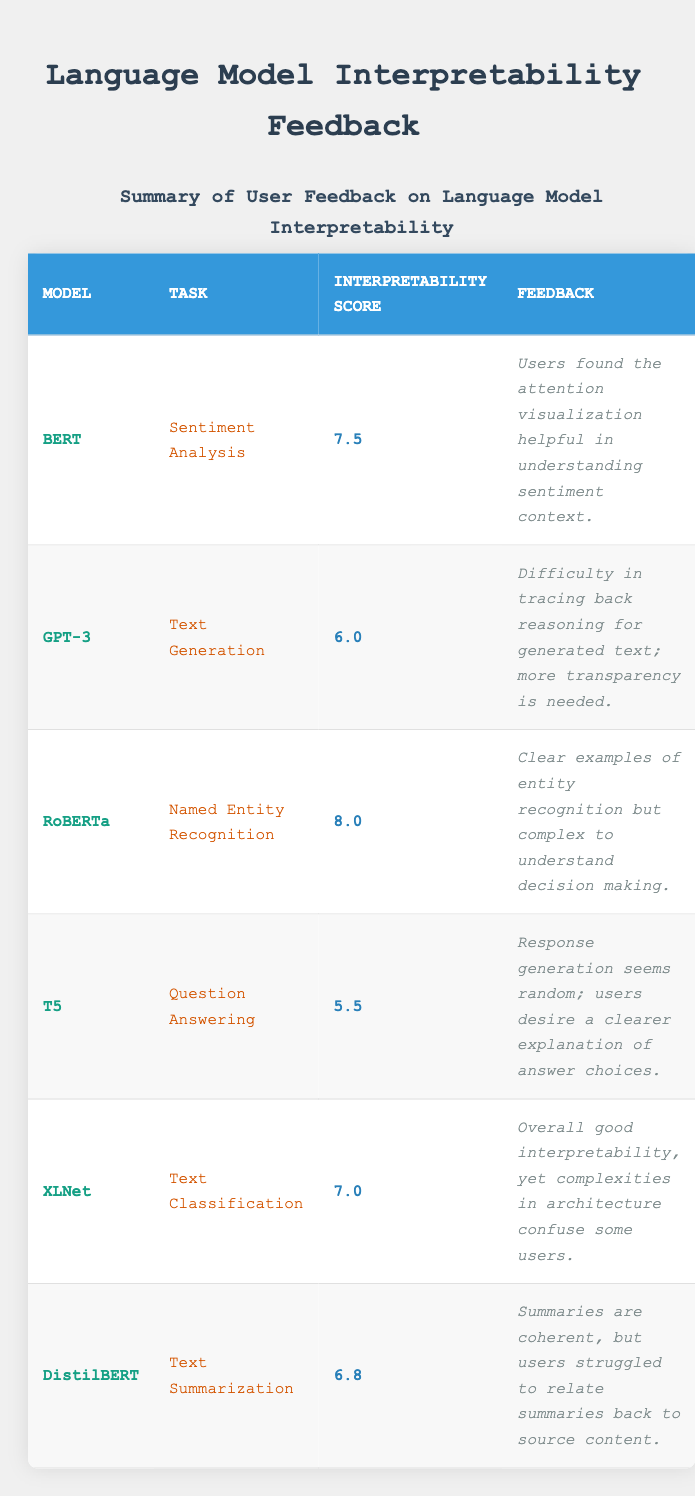What is the interpretability score for RoBERTa? The interpretability score for RoBERTa is found in the table under the "Interpretability Score" column, specifically for the row where the model is RoBERTa. The value provided is 8.0.
Answer: 8.0 Which model has the lowest interpretability score? To find the model with the lowest interpretability score, we compare the scores listed in the "Interpretability Score" column. The lowest score is 5.5, which corresponds to the T5 model.
Answer: T5 What feedback did users provide for the model with the highest interpretability score? The model with the highest interpretability score is RoBERTa, which scored 8.0. The feedback for RoBERTa is listed in the corresponding row and states that "Clear examples of entity recognition but complex to understand decision making."
Answer: Clear examples of entity recognition but complex to understand decision making Is the interpretability score for DistilBERT greater than 7? The interpretability score for DistilBERT is 6.8 as indicated in the table. Since 6.8 is less than 7, the statement is false.
Answer: No What is the average interpretability score of the models listed? To calculate the average interpretability score, we need to sum up all the scores: 7.5 (BERT) + 6.0 (GPT-3) + 8.0 (RoBERTa) + 5.5 (T5) + 7.0 (XLNet) + 6.8 (DistilBERT) = 40.8. There are 6 models, so the average is 40.8 / 6 = 6.8.
Answer: 6.8 How many models scored above 7 in interpretability? By reviewing the interpretability scores, we can see that BERT (7.5), RoBERTa (8.0), and XLNet (7.0) all scored above 7. This gives us a total of 3 models.
Answer: 3 Which task associated with T5 had the lowest interpretability score? The task for T5 is "Question Answering" and its interpretability score is 5.5, which is the lowest of all the listed models. Therefore, the task associated with T5 has the lowest interpretability score.
Answer: Question Answering Do users find the attention visualization helpful in understanding sentiment context? According to the feedback for the BERT model, users found the attention visualization helpful in understanding sentiment context, which indicates that the answer to the question is yes.
Answer: Yes What is the difference between the interpretability scores of BERT and GPT-3? The interpretability score for BERT is 7.5, and for GPT-3, it is 6.0. The difference is calculated as 7.5 - 6.0 = 1.5.
Answer: 1.5 